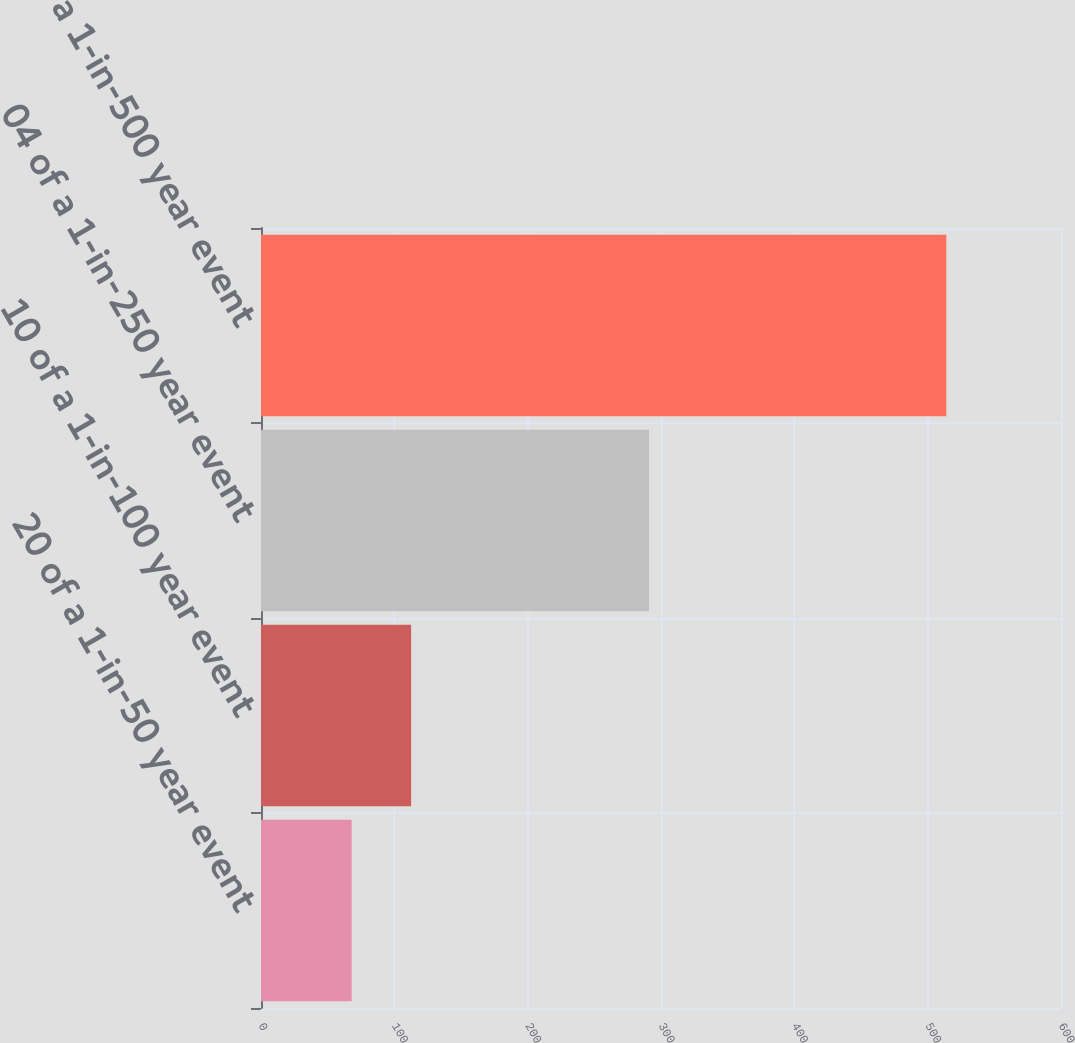Convert chart. <chart><loc_0><loc_0><loc_500><loc_500><bar_chart><fcel>20 of a 1-in-50 year event<fcel>10 of a 1-in-100 year event<fcel>04 of a 1-in-250 year event<fcel>02 of a 1-in-500 year event<nl><fcel>68<fcel>112.6<fcel>291<fcel>514<nl></chart> 